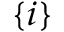<formula> <loc_0><loc_0><loc_500><loc_500>^ { \{ i \} }</formula> 